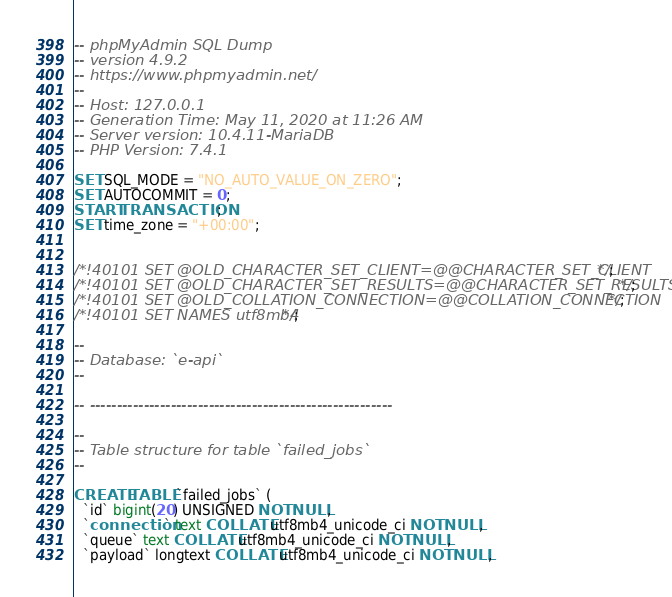Convert code to text. <code><loc_0><loc_0><loc_500><loc_500><_SQL_>-- phpMyAdmin SQL Dump
-- version 4.9.2
-- https://www.phpmyadmin.net/
--
-- Host: 127.0.0.1
-- Generation Time: May 11, 2020 at 11:26 AM
-- Server version: 10.4.11-MariaDB
-- PHP Version: 7.4.1

SET SQL_MODE = "NO_AUTO_VALUE_ON_ZERO";
SET AUTOCOMMIT = 0;
START TRANSACTION;
SET time_zone = "+00:00";


/*!40101 SET @OLD_CHARACTER_SET_CLIENT=@@CHARACTER_SET_CLIENT */;
/*!40101 SET @OLD_CHARACTER_SET_RESULTS=@@CHARACTER_SET_RESULTS */;
/*!40101 SET @OLD_COLLATION_CONNECTION=@@COLLATION_CONNECTION */;
/*!40101 SET NAMES utf8mb4 */;

--
-- Database: `e-api`
--

-- --------------------------------------------------------

--
-- Table structure for table `failed_jobs`
--

CREATE TABLE `failed_jobs` (
  `id` bigint(20) UNSIGNED NOT NULL,
  `connection` text COLLATE utf8mb4_unicode_ci NOT NULL,
  `queue` text COLLATE utf8mb4_unicode_ci NOT NULL,
  `payload` longtext COLLATE utf8mb4_unicode_ci NOT NULL,</code> 